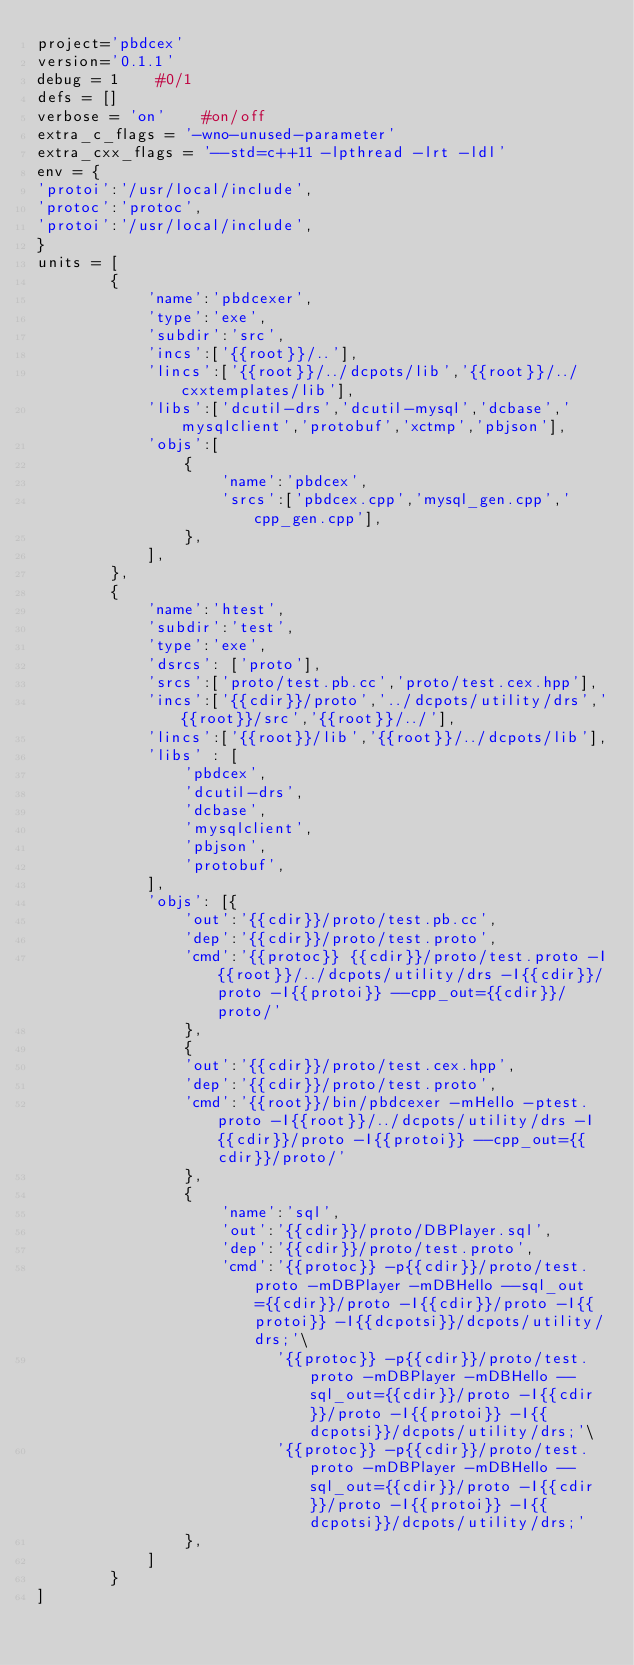<code> <loc_0><loc_0><loc_500><loc_500><_Python_>project='pbdcex'
version='0.1.1'
debug = 1    #0/1
defs = []
verbose = 'on'    #on/off
extra_c_flags = '-wno-unused-parameter'
extra_cxx_flags = '--std=c++11 -lpthread -lrt -ldl'
env = {
'protoi':'/usr/local/include',
'protoc':'protoc',
'protoi':'/usr/local/include',
}
units = [
        {
            'name':'pbdcexer',
            'type':'exe',
            'subdir':'src',
            'incs':['{{root}}/..'],
            'lincs':['{{root}}/../dcpots/lib','{{root}}/../cxxtemplates/lib'],
            'libs':['dcutil-drs','dcutil-mysql','dcbase','mysqlclient','protobuf','xctmp','pbjson'],
            'objs':[
                {
                    'name':'pbdcex',
                    'srcs':['pbdcex.cpp','mysql_gen.cpp','cpp_gen.cpp'],
                },
            ],
        },
        {
            'name':'htest',
            'subdir':'test',
            'type':'exe',
            'dsrcs': ['proto'],
            'srcs':['proto/test.pb.cc','proto/test.cex.hpp'],
            'incs':['{{cdir}}/proto','../dcpots/utility/drs','{{root}}/src','{{root}}/../'],
            'lincs':['{{root}}/lib','{{root}}/../dcpots/lib'],
            'libs' : [
                'pbdcex',
                'dcutil-drs',
                'dcbase',
                'mysqlclient',
                'pbjson',
                'protobuf',
            ],
            'objs': [{
                'out':'{{cdir}}/proto/test.pb.cc',
                'dep':'{{cdir}}/proto/test.proto',
                'cmd':'{{protoc}} {{cdir}}/proto/test.proto -I{{root}}/../dcpots/utility/drs -I{{cdir}}/proto -I{{protoi}} --cpp_out={{cdir}}/proto/'
                },
                {
                'out':'{{cdir}}/proto/test.cex.hpp',
                'dep':'{{cdir}}/proto/test.proto',
                'cmd':'{{root}}/bin/pbdcexer -mHello -ptest.proto -I{{root}}/../dcpots/utility/drs -I{{cdir}}/proto -I{{protoi}} --cpp_out={{cdir}}/proto/'
                },
                {
                    'name':'sql',
                    'out':'{{cdir}}/proto/DBPlayer.sql',
                    'dep':'{{cdir}}/proto/test.proto',
                    'cmd':'{{protoc}} -p{{cdir}}/proto/test.proto -mDBPlayer -mDBHello --sql_out={{cdir}}/proto -I{{cdir}}/proto -I{{protoi}} -I{{dcpotsi}}/dcpots/utility/drs;'\
                          '{{protoc}} -p{{cdir}}/proto/test.proto -mDBPlayer -mDBHello --sql_out={{cdir}}/proto -I{{cdir}}/proto -I{{protoi}} -I{{dcpotsi}}/dcpots/utility/drs;'\
                          '{{protoc}} -p{{cdir}}/proto/test.proto -mDBPlayer -mDBHello --sql_out={{cdir}}/proto -I{{cdir}}/proto -I{{protoi}} -I{{dcpotsi}}/dcpots/utility/drs;'
                },
            ]
        } 
]
</code> 